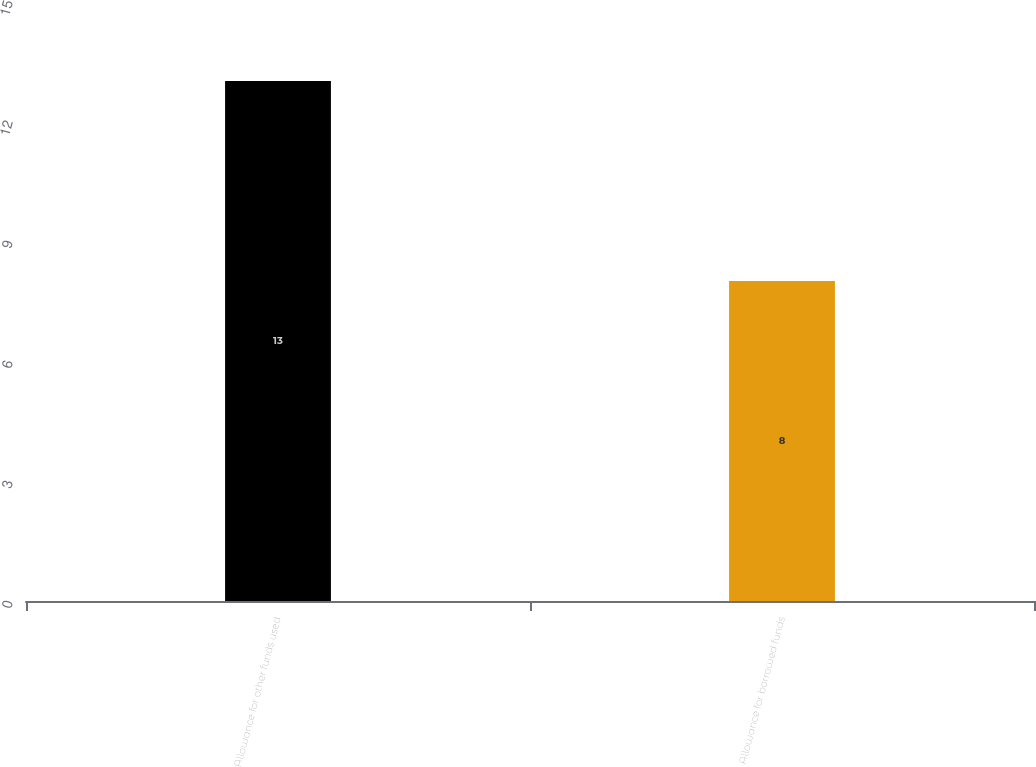Convert chart. <chart><loc_0><loc_0><loc_500><loc_500><bar_chart><fcel>Allowance for other funds used<fcel>Allowance for borrowed funds<nl><fcel>13<fcel>8<nl></chart> 